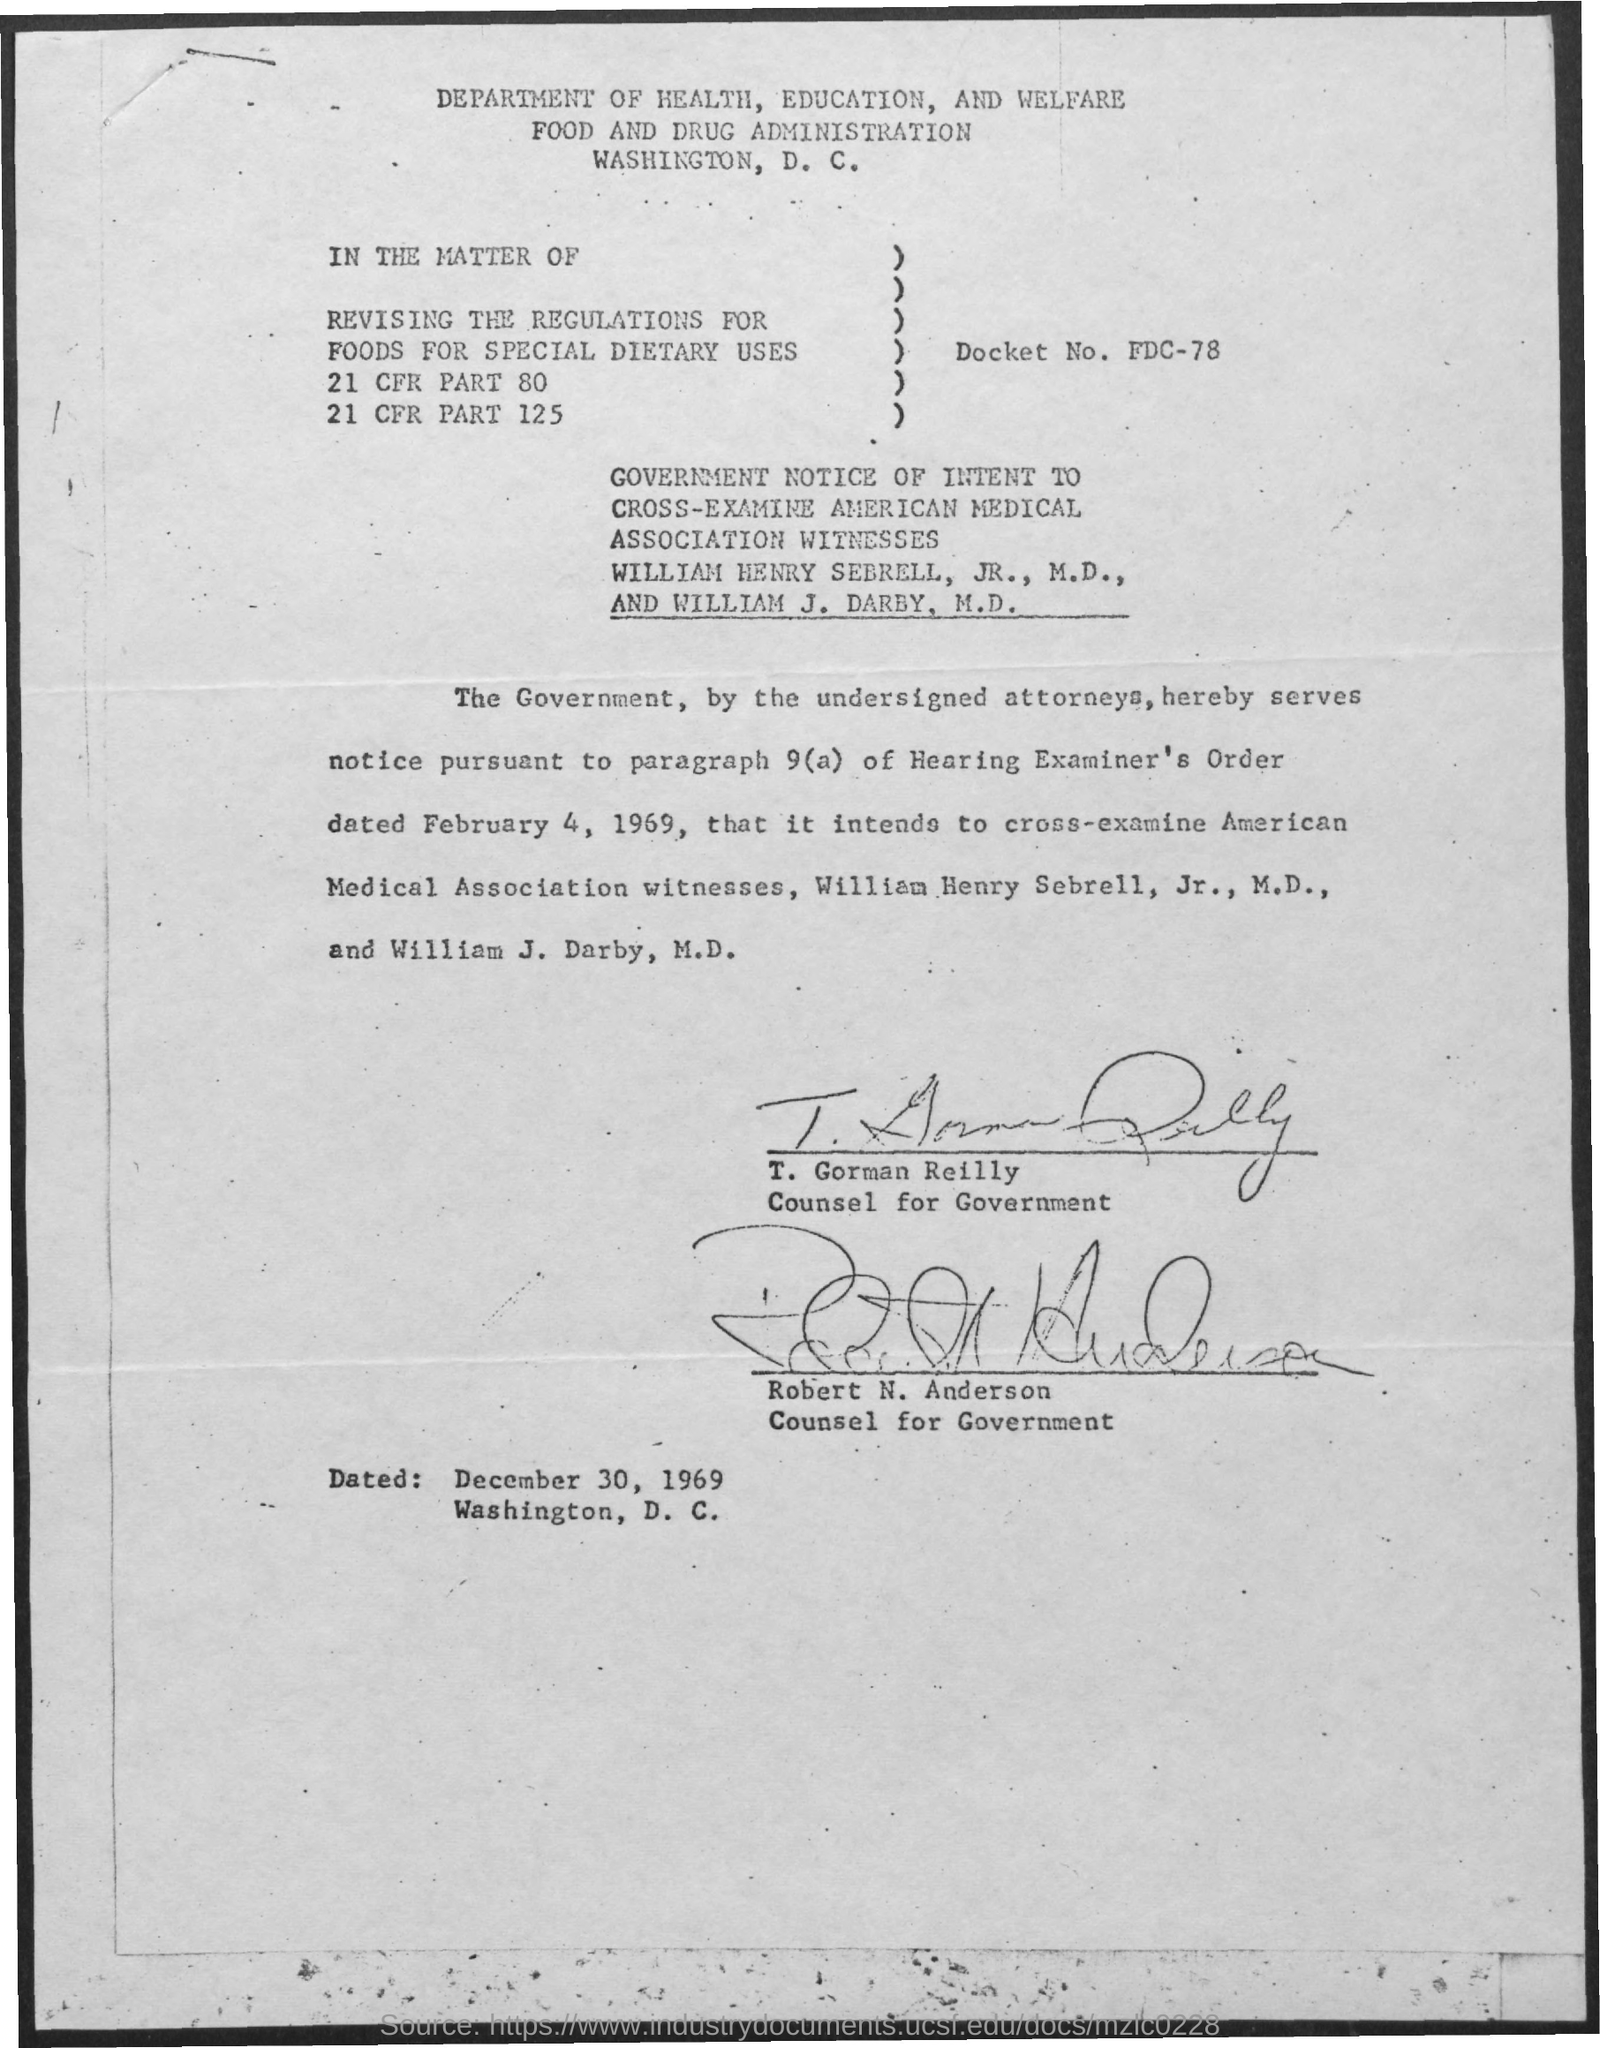Give some essential details in this illustration. T. Gorman Reilly is the counsel for the government. What is the docket number? It is FDC-78...". Robert N. Anderson is the counsel for the government. The Food and Drug Administration is the second title in the document. 